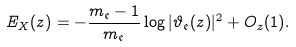<formula> <loc_0><loc_0><loc_500><loc_500>E _ { X } ( z ) = - \frac { m _ { \mathfrak { e } } - 1 } { m _ { \mathfrak { e } } } \log | \vartheta _ { \mathfrak { e } } ( z ) | ^ { 2 } + O _ { z } ( 1 ) .</formula> 